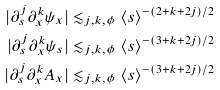<formula> <loc_0><loc_0><loc_500><loc_500>| \partial _ { s } ^ { j } \partial _ { x } ^ { k } \psi _ { x } | & \lesssim _ { j , k , \phi } \langle s \rangle ^ { - ( 2 + k + 2 j ) / 2 } \\ | \partial _ { s } ^ { j } \partial _ { x } ^ { k } \psi _ { s } | & \lesssim _ { j , k , \phi } \langle s \rangle ^ { - ( 3 + k + 2 j ) / 2 } \\ | \partial _ { s } ^ { j } \partial _ { x } ^ { k } A _ { x } | & \lesssim _ { j , k , \phi } \langle s \rangle ^ { - ( 3 + k + 2 j ) / 2 }</formula> 